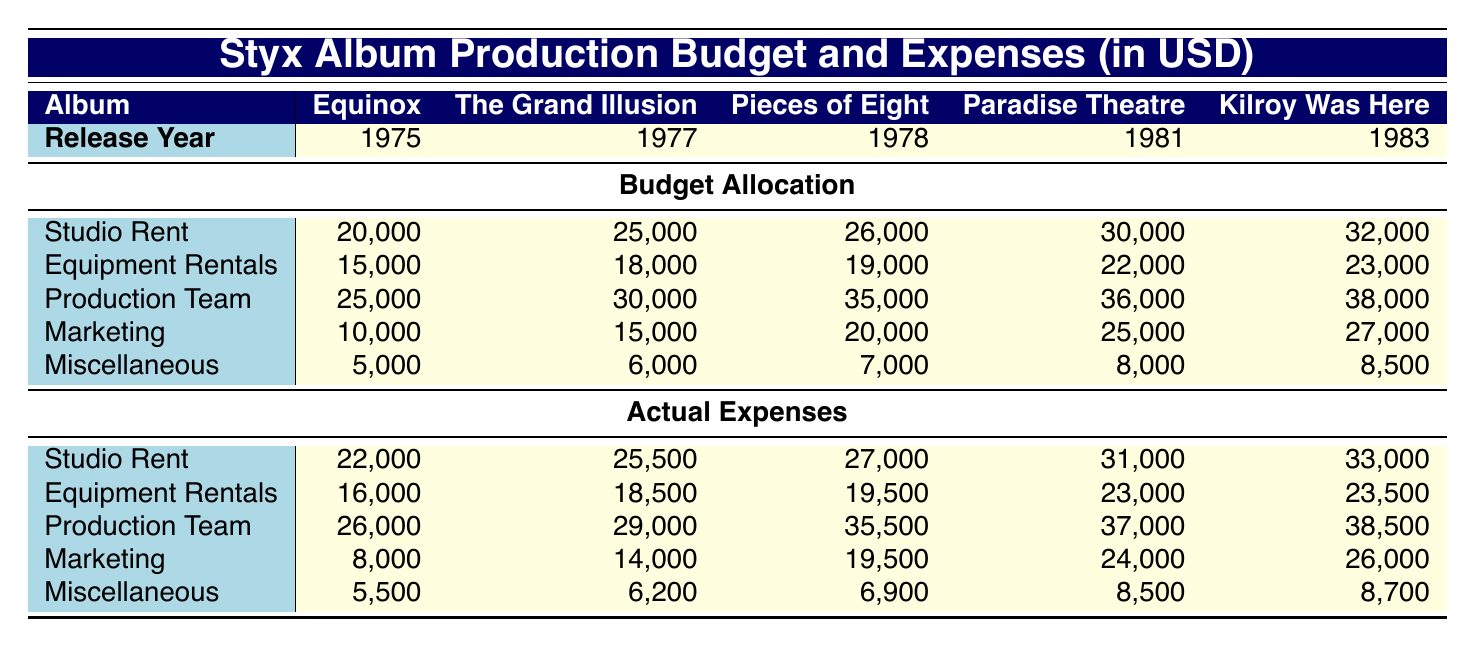What was the budget allocation for studio rent for the album "Pieces of Eight"? The table shows the budget allocation for studio rent for the album "Pieces of Eight" under the corresponding column. The value is 26,000.
Answer: 26,000 What are the actual expenses for marketing for the album "Kilroy Was Here"? The table shows the actual expenses for marketing for "Kilroy Was Here" under the relevant column. The value is 26,000.
Answer: 26,000 Did the actual expenses for “Equinox” exceed the budget allocation for the production team? In the table, the budget allocation for the production team for "Equinox" is 25,000, and the actual expenses are 26,000. Since 26,000 is greater than 25,000, the answer is yes.
Answer: Yes What was the total budget allocation for the album "The Grand Illusion"? To find this, we sum the budget allocations for all categories under "The Grand Illusion": 25,000 (studio rent) + 18,000 (equipment rentals) + 30,000 (production team) + 15,000 (marketing) + 6,000 (miscellaneous) = 94,000.
Answer: 94,000 Is it true that the studio rent expense for "Paradise Theatre" was lower than that of "Kilroy Was Here"? The actual expenses for studio rent for "Paradise Theatre" is 31,000 and for "Kilroy Was Here" is 33,000. Since 31,000 is less than 33,000, the answer is yes.
Answer: Yes What was the difference in budget allocation for miscellaneous expenses between "Pieces of Eight" and "Equinox"? The budget allocation for miscellaneous expenses for "Pieces of Eight" is 7,000 and for "Equinox" is 5,000. The difference is 7,000 - 5,000 = 2,000.
Answer: 2,000 Which album had the highest budget allocation for the production team? By looking at the production team category, the maximum value is found for "Pieces of Eight" at 35,000, which is higher than the other albums.
Answer: Pieces of Eight What was the average actual expense for equipment rentals across all albums? To calculate the average, we sum the actual expenses for equipment rentals: 16,000 + 18,500 + 19,500 + 23,000 + 23,500 = 100,500. Since there are 5 albums, we divide by 5: 100,500 / 5 = 20,100.
Answer: 20,100 Did "The Grand Illusion" have a higher miscellaneous budget allocation than "Paradise Theatre"? The budget allocation for miscellaneous for "The Grand Illusion" is 6,000 and for "Paradise Theatre" is 8,000. Since 6,000 is less than 8,000, the answer is no.
Answer: No 